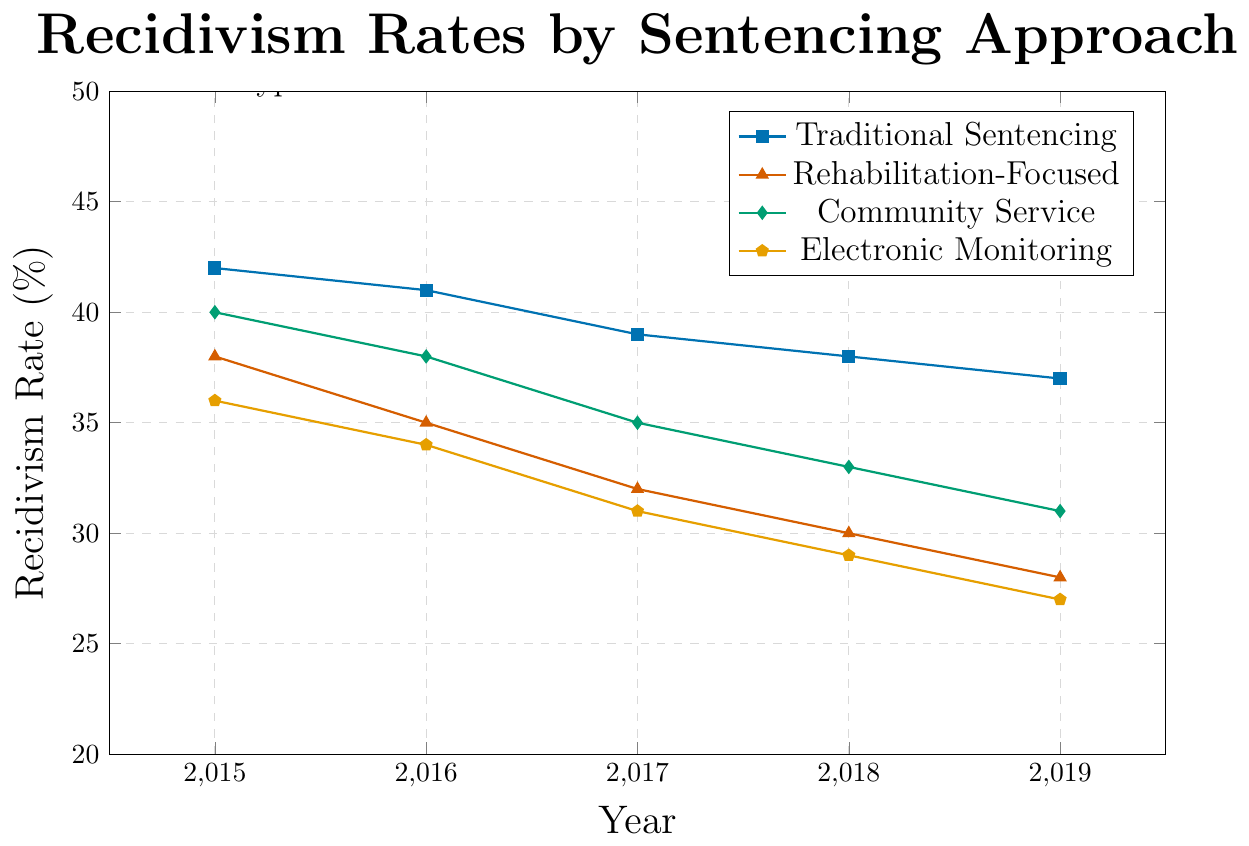What is the recidivism rate for Theft in 2019 under Electronic Monitoring? Find the point corresponding to 2019 along the x-axis and Electronic Monitoring among the plotted lines. The value at this point is the recidivism rate for 2019 under Electronic Monitoring.
Answer: 27 Which sentencing approach shows the greatest overall decrease in recidivism rates for Theft from 2015 to 2019? Calculate the difference between the recidivism rates for 2015 and 2019 for each approach. The approach with the highest decrease is the answer.
Answer: Rehabilitation-Focused In 2017, how much higher is the recidivism rate for Theft under Traditional Sentencing compared to Community Service? Find the recidivism rates for both Traditional Sentencing and Community Service in 2017 and subtract the Community Service rate from the Traditional Sentencing rate.
Answer: 4 What is the average recidivism rate for Theft under Traditional Sentencing from 2015 to 2019? Sum the recidivism rates for Traditional Sentencing from 2015 to 2019, then divide by the number of years (5) to get the average.
Answer: 39.4 For which year and sentencing approach does Theft have the lowest recidivism rate? Compare recidivism rates across all years and approaches and identify the lowest value along with the corresponding year and approach.
Answer: 2019, Electronic Monitoring Describe the trend in recidivism rates for Theft under Community Service from 2015 to 2019. Observe the change in recidivism rates for Community Service by noting its values from 2015 to 2019 to determine whether it is increasing, decreasing, or stable.
Answer: Decreasing How does the recidivism rate for Theft under Rehabilitation-Focused sentencing in 2016 compare to that under Electronic Monitoring in 2017? Locate the recidivism rates for Rehabilitation-Focused sentencing in 2016 and Electronic Monitoring in 2017, then make a direct comparison.
Answer: They are equal What is the total decrease in recidivism rate for Theft under Electronic Monitoring from 2015 to 2019? Subtract the recidivism rate in 2019 from that in 2015 for Electronic Monitoring to get the total decrease.
Answer: 9 Which sentencing approach consistently shows the lowest recidivism rates for Theft across all years? Compare the recidivism rates for each approach across all years and determine which approach has the lowest rates consistently.
Answer: Electronic Monitoring 